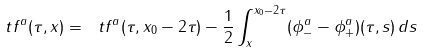<formula> <loc_0><loc_0><loc_500><loc_500>\ t f ^ { a } ( \tau , x ) = \ t f ^ { a } ( \tau , x _ { 0 } - 2 \tau ) - \frac { 1 } { 2 } \int _ { x } ^ { x _ { 0 } - 2 \tau } ( \phi ^ { a } _ { - } - \phi ^ { a } _ { + } ) ( \tau , s ) \, d s</formula> 